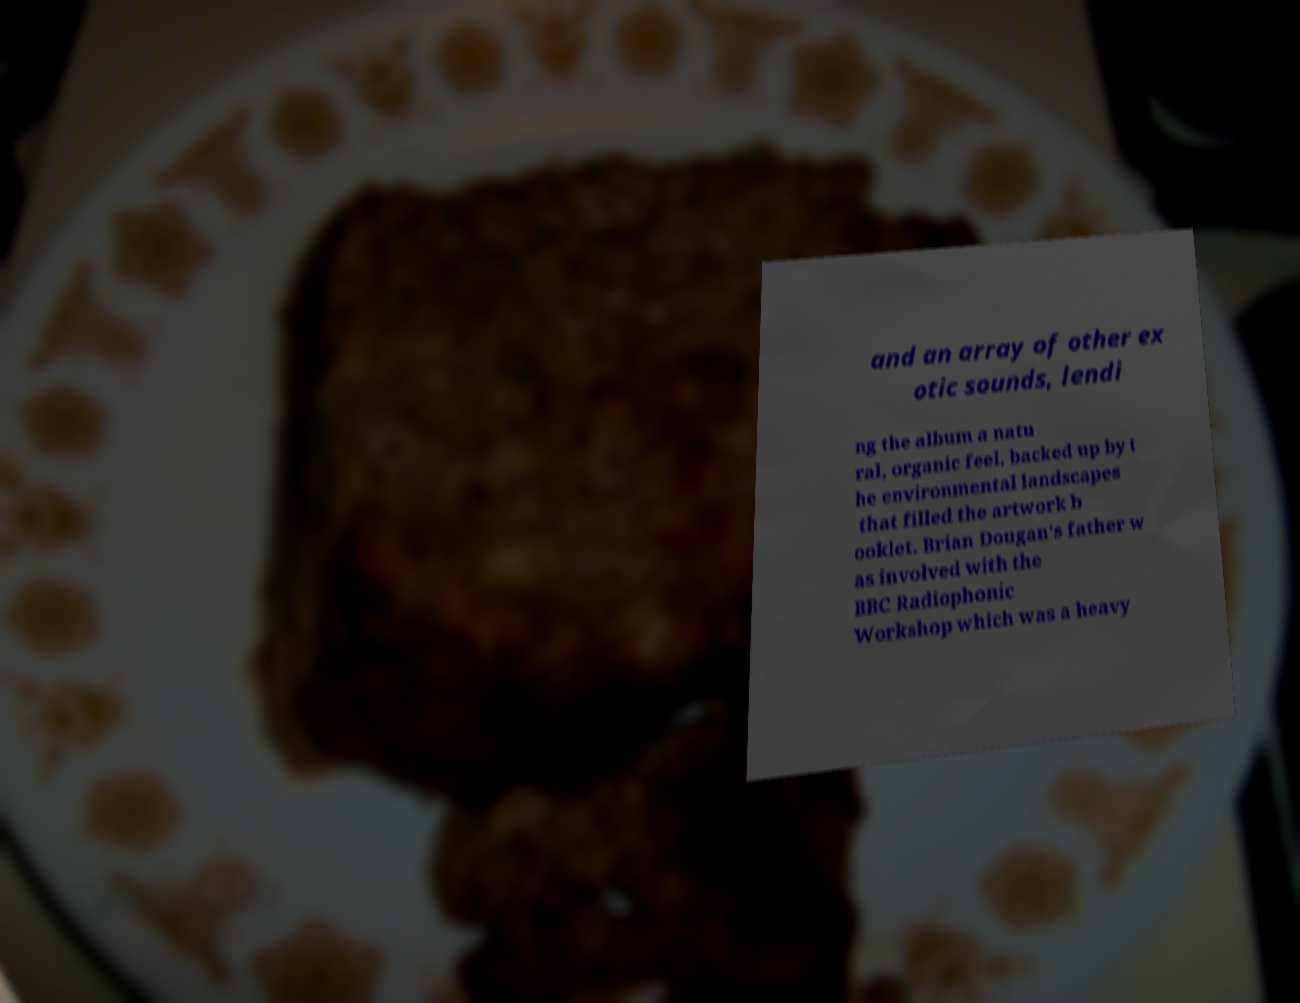There's text embedded in this image that I need extracted. Can you transcribe it verbatim? and an array of other ex otic sounds, lendi ng the album a natu ral, organic feel, backed up by t he environmental landscapes that filled the artwork b ooklet. Brian Dougan's father w as involved with the BBC Radiophonic Workshop which was a heavy 